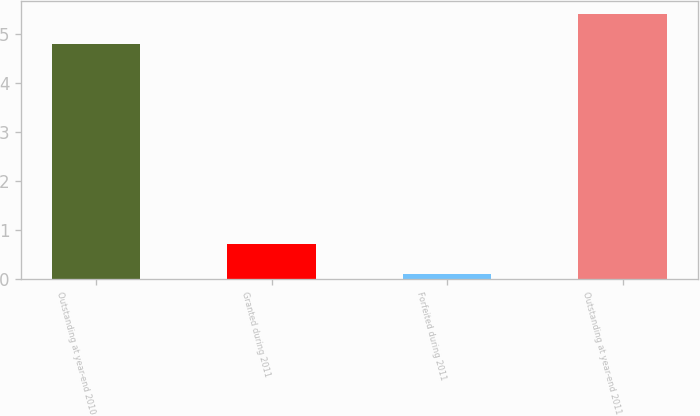<chart> <loc_0><loc_0><loc_500><loc_500><bar_chart><fcel>Outstanding at year-end 2010<fcel>Granted during 2011<fcel>Forfeited during 2011<fcel>Outstanding at year-end 2011<nl><fcel>4.8<fcel>0.7<fcel>0.1<fcel>5.4<nl></chart> 